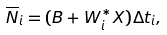<formula> <loc_0><loc_0><loc_500><loc_500>\overline { N } _ { i } = ( B + W _ { i } ^ { \ast } X ) \Delta t _ { i } ,</formula> 